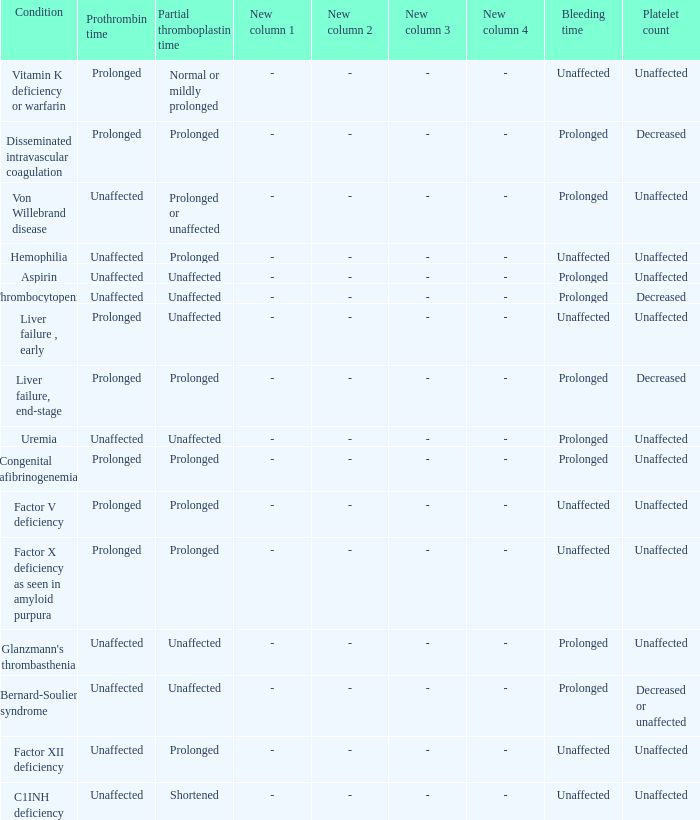When factor x deficiency is present in amyloid purpura, how long does the bleeding time last? Unaffected. 